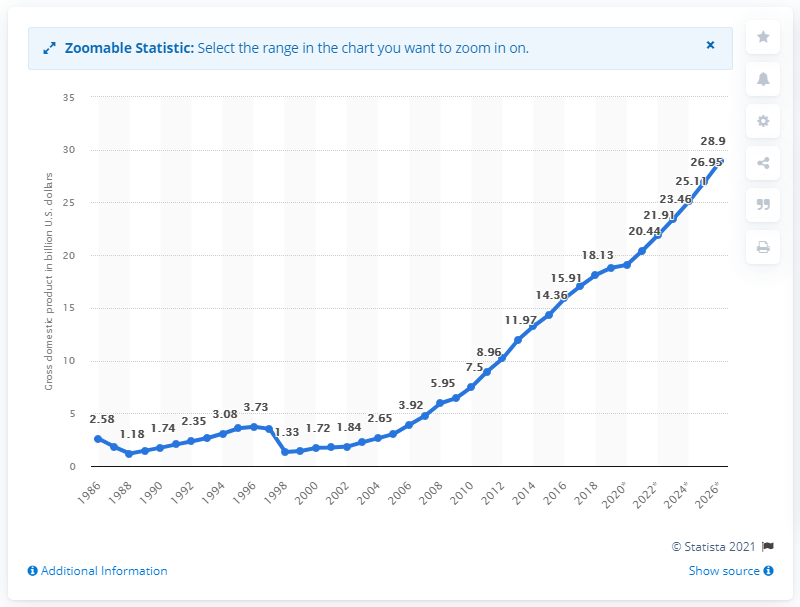Point out several critical features in this image. Laos' Gross Domestic Product (GDP) in 2019 was 18.81. 